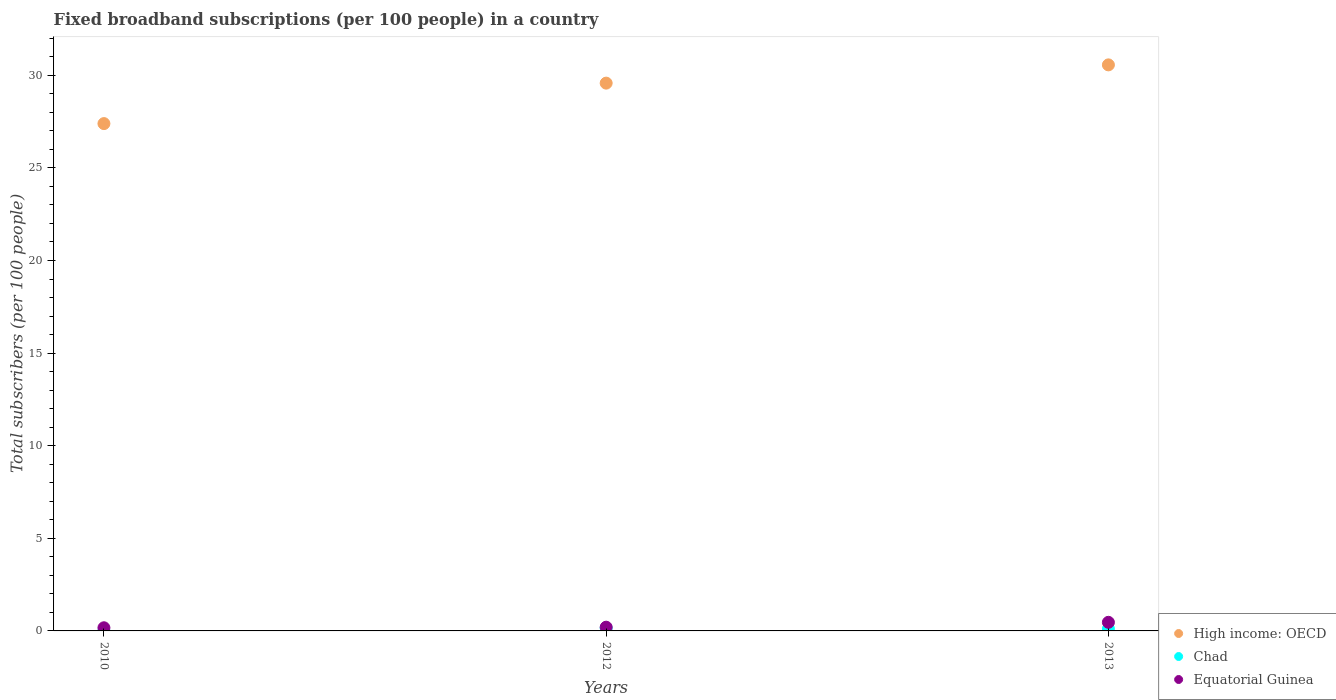How many different coloured dotlines are there?
Provide a succinct answer. 3. What is the number of broadband subscriptions in Equatorial Guinea in 2010?
Your answer should be compact. 0.17. Across all years, what is the maximum number of broadband subscriptions in Chad?
Your response must be concise. 0.16. Across all years, what is the minimum number of broadband subscriptions in Equatorial Guinea?
Give a very brief answer. 0.17. In which year was the number of broadband subscriptions in Chad minimum?
Make the answer very short. 2010. What is the total number of broadband subscriptions in Chad in the graph?
Make the answer very short. 0.27. What is the difference between the number of broadband subscriptions in Equatorial Guinea in 2012 and that in 2013?
Give a very brief answer. -0.26. What is the difference between the number of broadband subscriptions in High income: OECD in 2013 and the number of broadband subscriptions in Chad in 2012?
Provide a succinct answer. 30.41. What is the average number of broadband subscriptions in Chad per year?
Ensure brevity in your answer.  0.09. In the year 2010, what is the difference between the number of broadband subscriptions in High income: OECD and number of broadband subscriptions in Chad?
Offer a terse response. 27.39. What is the ratio of the number of broadband subscriptions in Equatorial Guinea in 2012 to that in 2013?
Your answer should be compact. 0.43. What is the difference between the highest and the second highest number of broadband subscriptions in Chad?
Your response must be concise. 0.04. What is the difference between the highest and the lowest number of broadband subscriptions in High income: OECD?
Provide a succinct answer. 3.17. Is the sum of the number of broadband subscriptions in Equatorial Guinea in 2010 and 2012 greater than the maximum number of broadband subscriptions in High income: OECD across all years?
Provide a succinct answer. No. Is it the case that in every year, the sum of the number of broadband subscriptions in High income: OECD and number of broadband subscriptions in Equatorial Guinea  is greater than the number of broadband subscriptions in Chad?
Keep it short and to the point. Yes. Does the number of broadband subscriptions in Equatorial Guinea monotonically increase over the years?
Your answer should be compact. Yes. Is the number of broadband subscriptions in Chad strictly less than the number of broadband subscriptions in High income: OECD over the years?
Your answer should be compact. Yes. How many dotlines are there?
Ensure brevity in your answer.  3. What is the difference between two consecutive major ticks on the Y-axis?
Provide a succinct answer. 5. Does the graph contain grids?
Your answer should be very brief. No. Where does the legend appear in the graph?
Offer a very short reply. Bottom right. How are the legend labels stacked?
Give a very brief answer. Vertical. What is the title of the graph?
Make the answer very short. Fixed broadband subscriptions (per 100 people) in a country. Does "Togo" appear as one of the legend labels in the graph?
Ensure brevity in your answer.  No. What is the label or title of the X-axis?
Ensure brevity in your answer.  Years. What is the label or title of the Y-axis?
Provide a short and direct response. Total subscribers (per 100 people). What is the Total subscribers (per 100 people) of High income: OECD in 2010?
Make the answer very short. 27.39. What is the Total subscribers (per 100 people) of Chad in 2010?
Your answer should be compact. 0. What is the Total subscribers (per 100 people) of Equatorial Guinea in 2010?
Provide a succinct answer. 0.17. What is the Total subscribers (per 100 people) in High income: OECD in 2012?
Provide a succinct answer. 29.58. What is the Total subscribers (per 100 people) of Chad in 2012?
Your answer should be compact. 0.16. What is the Total subscribers (per 100 people) of Equatorial Guinea in 2012?
Your answer should be compact. 0.2. What is the Total subscribers (per 100 people) of High income: OECD in 2013?
Offer a terse response. 30.56. What is the Total subscribers (per 100 people) in Chad in 2013?
Provide a short and direct response. 0.11. What is the Total subscribers (per 100 people) of Equatorial Guinea in 2013?
Ensure brevity in your answer.  0.46. Across all years, what is the maximum Total subscribers (per 100 people) in High income: OECD?
Your response must be concise. 30.56. Across all years, what is the maximum Total subscribers (per 100 people) of Chad?
Provide a short and direct response. 0.16. Across all years, what is the maximum Total subscribers (per 100 people) of Equatorial Guinea?
Make the answer very short. 0.46. Across all years, what is the minimum Total subscribers (per 100 people) in High income: OECD?
Make the answer very short. 27.39. Across all years, what is the minimum Total subscribers (per 100 people) of Chad?
Your answer should be compact. 0. Across all years, what is the minimum Total subscribers (per 100 people) of Equatorial Guinea?
Your answer should be compact. 0.17. What is the total Total subscribers (per 100 people) of High income: OECD in the graph?
Your answer should be very brief. 87.53. What is the total Total subscribers (per 100 people) in Chad in the graph?
Provide a succinct answer. 0.27. What is the total Total subscribers (per 100 people) in Equatorial Guinea in the graph?
Offer a very short reply. 0.84. What is the difference between the Total subscribers (per 100 people) in High income: OECD in 2010 and that in 2012?
Provide a short and direct response. -2.19. What is the difference between the Total subscribers (per 100 people) of Chad in 2010 and that in 2012?
Give a very brief answer. -0.15. What is the difference between the Total subscribers (per 100 people) in Equatorial Guinea in 2010 and that in 2012?
Your response must be concise. -0.03. What is the difference between the Total subscribers (per 100 people) in High income: OECD in 2010 and that in 2013?
Keep it short and to the point. -3.17. What is the difference between the Total subscribers (per 100 people) of Chad in 2010 and that in 2013?
Offer a very short reply. -0.11. What is the difference between the Total subscribers (per 100 people) in Equatorial Guinea in 2010 and that in 2013?
Provide a succinct answer. -0.29. What is the difference between the Total subscribers (per 100 people) in High income: OECD in 2012 and that in 2013?
Give a very brief answer. -0.99. What is the difference between the Total subscribers (per 100 people) of Chad in 2012 and that in 2013?
Offer a very short reply. 0.04. What is the difference between the Total subscribers (per 100 people) of Equatorial Guinea in 2012 and that in 2013?
Provide a succinct answer. -0.26. What is the difference between the Total subscribers (per 100 people) of High income: OECD in 2010 and the Total subscribers (per 100 people) of Chad in 2012?
Keep it short and to the point. 27.23. What is the difference between the Total subscribers (per 100 people) in High income: OECD in 2010 and the Total subscribers (per 100 people) in Equatorial Guinea in 2012?
Provide a succinct answer. 27.19. What is the difference between the Total subscribers (per 100 people) in Chad in 2010 and the Total subscribers (per 100 people) in Equatorial Guinea in 2012?
Make the answer very short. -0.2. What is the difference between the Total subscribers (per 100 people) in High income: OECD in 2010 and the Total subscribers (per 100 people) in Chad in 2013?
Give a very brief answer. 27.28. What is the difference between the Total subscribers (per 100 people) of High income: OECD in 2010 and the Total subscribers (per 100 people) of Equatorial Guinea in 2013?
Keep it short and to the point. 26.93. What is the difference between the Total subscribers (per 100 people) of Chad in 2010 and the Total subscribers (per 100 people) of Equatorial Guinea in 2013?
Give a very brief answer. -0.46. What is the difference between the Total subscribers (per 100 people) in High income: OECD in 2012 and the Total subscribers (per 100 people) in Chad in 2013?
Make the answer very short. 29.46. What is the difference between the Total subscribers (per 100 people) in High income: OECD in 2012 and the Total subscribers (per 100 people) in Equatorial Guinea in 2013?
Offer a terse response. 29.11. What is the difference between the Total subscribers (per 100 people) of Chad in 2012 and the Total subscribers (per 100 people) of Equatorial Guinea in 2013?
Provide a succinct answer. -0.31. What is the average Total subscribers (per 100 people) of High income: OECD per year?
Make the answer very short. 29.18. What is the average Total subscribers (per 100 people) in Chad per year?
Provide a succinct answer. 0.09. What is the average Total subscribers (per 100 people) of Equatorial Guinea per year?
Your answer should be compact. 0.28. In the year 2010, what is the difference between the Total subscribers (per 100 people) of High income: OECD and Total subscribers (per 100 people) of Chad?
Your answer should be compact. 27.39. In the year 2010, what is the difference between the Total subscribers (per 100 people) of High income: OECD and Total subscribers (per 100 people) of Equatorial Guinea?
Offer a very short reply. 27.22. In the year 2010, what is the difference between the Total subscribers (per 100 people) of Chad and Total subscribers (per 100 people) of Equatorial Guinea?
Keep it short and to the point. -0.17. In the year 2012, what is the difference between the Total subscribers (per 100 people) of High income: OECD and Total subscribers (per 100 people) of Chad?
Keep it short and to the point. 29.42. In the year 2012, what is the difference between the Total subscribers (per 100 people) in High income: OECD and Total subscribers (per 100 people) in Equatorial Guinea?
Ensure brevity in your answer.  29.38. In the year 2012, what is the difference between the Total subscribers (per 100 people) in Chad and Total subscribers (per 100 people) in Equatorial Guinea?
Your answer should be compact. -0.04. In the year 2013, what is the difference between the Total subscribers (per 100 people) in High income: OECD and Total subscribers (per 100 people) in Chad?
Provide a succinct answer. 30.45. In the year 2013, what is the difference between the Total subscribers (per 100 people) in High income: OECD and Total subscribers (per 100 people) in Equatorial Guinea?
Your response must be concise. 30.1. In the year 2013, what is the difference between the Total subscribers (per 100 people) in Chad and Total subscribers (per 100 people) in Equatorial Guinea?
Your answer should be very brief. -0.35. What is the ratio of the Total subscribers (per 100 people) of High income: OECD in 2010 to that in 2012?
Provide a succinct answer. 0.93. What is the ratio of the Total subscribers (per 100 people) in Chad in 2010 to that in 2012?
Your answer should be very brief. 0.02. What is the ratio of the Total subscribers (per 100 people) in Equatorial Guinea in 2010 to that in 2012?
Your answer should be very brief. 0.85. What is the ratio of the Total subscribers (per 100 people) in High income: OECD in 2010 to that in 2013?
Give a very brief answer. 0.9. What is the ratio of the Total subscribers (per 100 people) in Chad in 2010 to that in 2013?
Your answer should be very brief. 0.02. What is the ratio of the Total subscribers (per 100 people) of Equatorial Guinea in 2010 to that in 2013?
Provide a short and direct response. 0.37. What is the ratio of the Total subscribers (per 100 people) in High income: OECD in 2012 to that in 2013?
Offer a terse response. 0.97. What is the ratio of the Total subscribers (per 100 people) in Chad in 2012 to that in 2013?
Ensure brevity in your answer.  1.36. What is the ratio of the Total subscribers (per 100 people) of Equatorial Guinea in 2012 to that in 2013?
Provide a succinct answer. 0.43. What is the difference between the highest and the second highest Total subscribers (per 100 people) in High income: OECD?
Offer a terse response. 0.99. What is the difference between the highest and the second highest Total subscribers (per 100 people) of Chad?
Ensure brevity in your answer.  0.04. What is the difference between the highest and the second highest Total subscribers (per 100 people) of Equatorial Guinea?
Keep it short and to the point. 0.26. What is the difference between the highest and the lowest Total subscribers (per 100 people) of High income: OECD?
Ensure brevity in your answer.  3.17. What is the difference between the highest and the lowest Total subscribers (per 100 people) in Chad?
Provide a short and direct response. 0.15. What is the difference between the highest and the lowest Total subscribers (per 100 people) of Equatorial Guinea?
Ensure brevity in your answer.  0.29. 